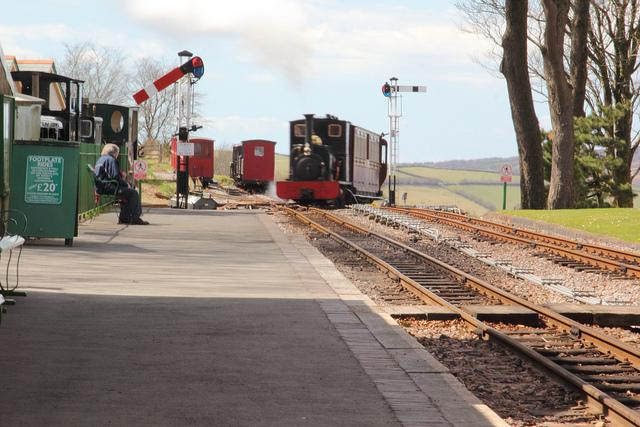What type facility is shown? Please explain your reasoning. train depot. A train station is next to the train tracks. 